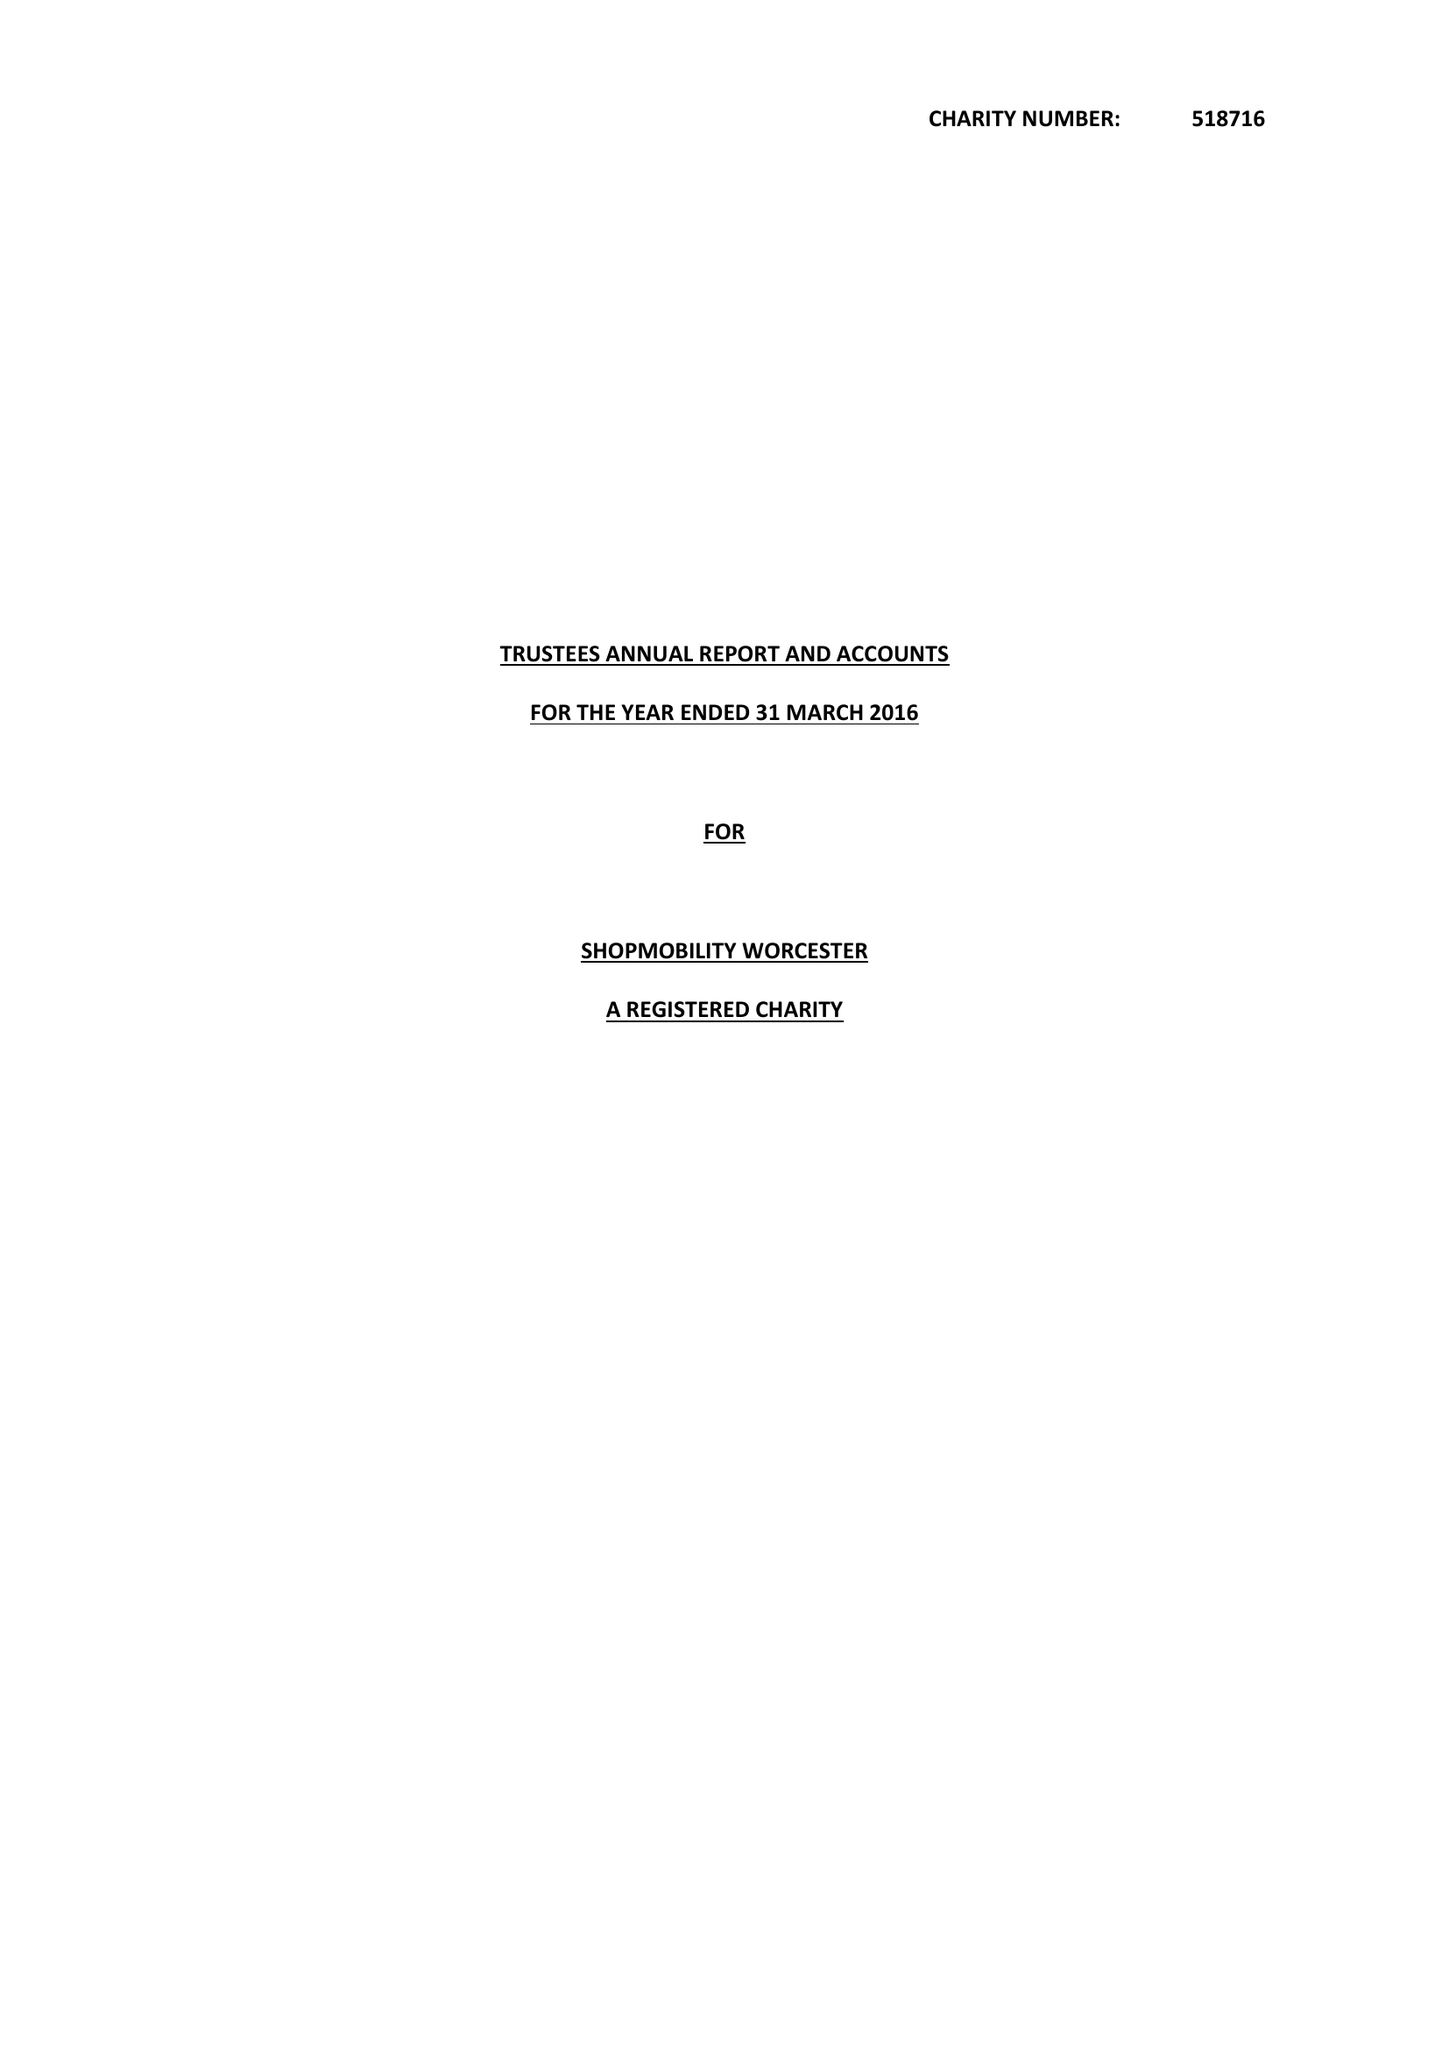What is the value for the address__street_line?
Answer the question using a single word or phrase. None 